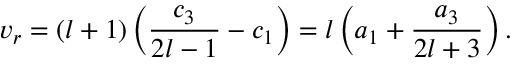<formula> <loc_0><loc_0><loc_500><loc_500>v _ { r } = ( l + 1 ) \left ( \frac { c _ { 3 } } { 2 l - 1 } - c _ { 1 } \right ) = l \left ( a _ { 1 } + \frac { a _ { 3 } } { 2 l + 3 } \right ) .</formula> 